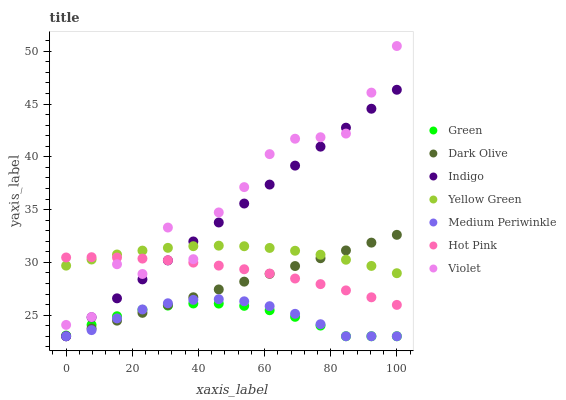Does Green have the minimum area under the curve?
Answer yes or no. Yes. Does Violet have the maximum area under the curve?
Answer yes or no. Yes. Does Indigo have the minimum area under the curve?
Answer yes or no. No. Does Indigo have the maximum area under the curve?
Answer yes or no. No. Is Dark Olive the smoothest?
Answer yes or no. Yes. Is Violet the roughest?
Answer yes or no. Yes. Is Indigo the smoothest?
Answer yes or no. No. Is Indigo the roughest?
Answer yes or no. No. Does Dark Olive have the lowest value?
Answer yes or no. Yes. Does Yellow Green have the lowest value?
Answer yes or no. No. Does Violet have the highest value?
Answer yes or no. Yes. Does Indigo have the highest value?
Answer yes or no. No. Is Medium Periwinkle less than Yellow Green?
Answer yes or no. Yes. Is Violet greater than Medium Periwinkle?
Answer yes or no. Yes. Does Green intersect Dark Olive?
Answer yes or no. Yes. Is Green less than Dark Olive?
Answer yes or no. No. Is Green greater than Dark Olive?
Answer yes or no. No. Does Medium Periwinkle intersect Yellow Green?
Answer yes or no. No. 